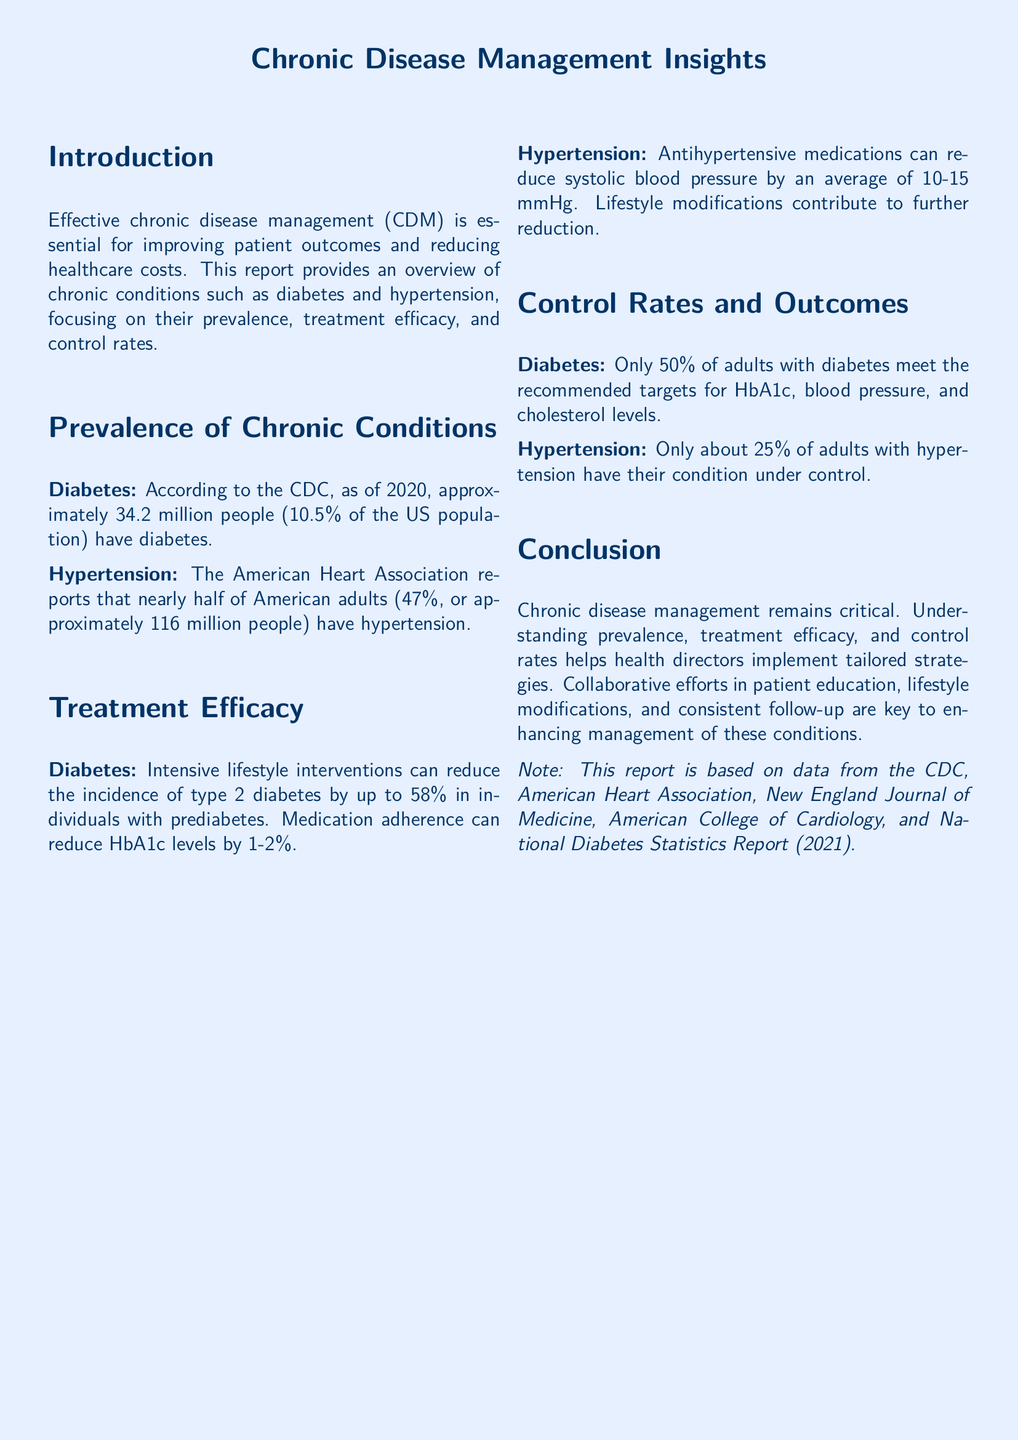what is the percentage of the US population that has diabetes? According to the CDC, approximately 10.5% of the US population has diabetes.
Answer: 10.5% how many people in the US have hypertension? The American Heart Association reports that approximately 116 million people have hypertension.
Answer: 116 million what is the reduction in incidence of type 2 diabetes with intensive lifestyle interventions? It can reduce the incidence of type 2 diabetes by up to 58%.
Answer: 58% what percentage of adults with diabetes meet recommended targets for control? Only 50% of adults with diabetes meet the recommended targets.
Answer: 50% what is the average reduction in systolic blood pressure from antihypertensive medications? Antihypertensive medications can reduce systolic blood pressure by an average of 10-15 mmHg.
Answer: 10-15 mmHg what percentage of adults with hypertension have their condition under control? Only about 25% of adults with hypertension have their condition under control.
Answer: 25% what types of interventions are key for enhancing chronic disease management? Patient education, lifestyle modifications, and consistent follow-up are key interventions.
Answer: Patient education, lifestyle modifications, and consistent follow-up who is the target audience for this report? The report is aimed at health directors implementing strategies for chronic disease management.
Answer: Health directors what is the report based on? The report is based on data from the CDC and other health organizations.
Answer: Data from the CDC, American Heart Association, and others 